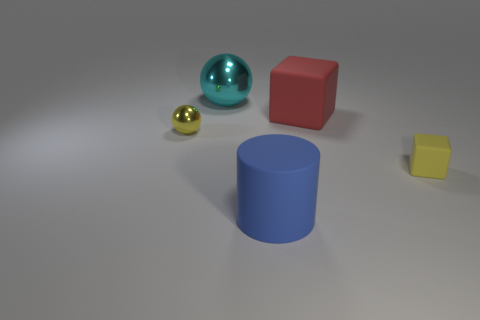Are there any other rubber things that have the same shape as the cyan object?
Make the answer very short. No. The cube that is to the left of the yellow thing that is right of the small yellow object to the left of the cyan shiny object is what color?
Your answer should be compact. Red. What number of matte things are either red cubes or cyan spheres?
Make the answer very short. 1. Is the number of big cyan metallic spheres that are on the left side of the blue cylinder greater than the number of spheres left of the cyan thing?
Offer a very short reply. No. How many other things are there of the same size as the yellow rubber object?
Ensure brevity in your answer.  1. What is the size of the shiny object to the right of the yellow object that is on the left side of the cyan thing?
Give a very brief answer. Large. What number of large things are either blue cylinders or blocks?
Provide a short and direct response. 2. There is a shiny ball that is behind the yellow thing to the left of the large cube on the right side of the big matte cylinder; how big is it?
Keep it short and to the point. Large. Is there anything else of the same color as the large cube?
Your answer should be very brief. No. There is a sphere that is in front of the big red rubber thing behind the tiny object right of the cyan ball; what is it made of?
Make the answer very short. Metal. 